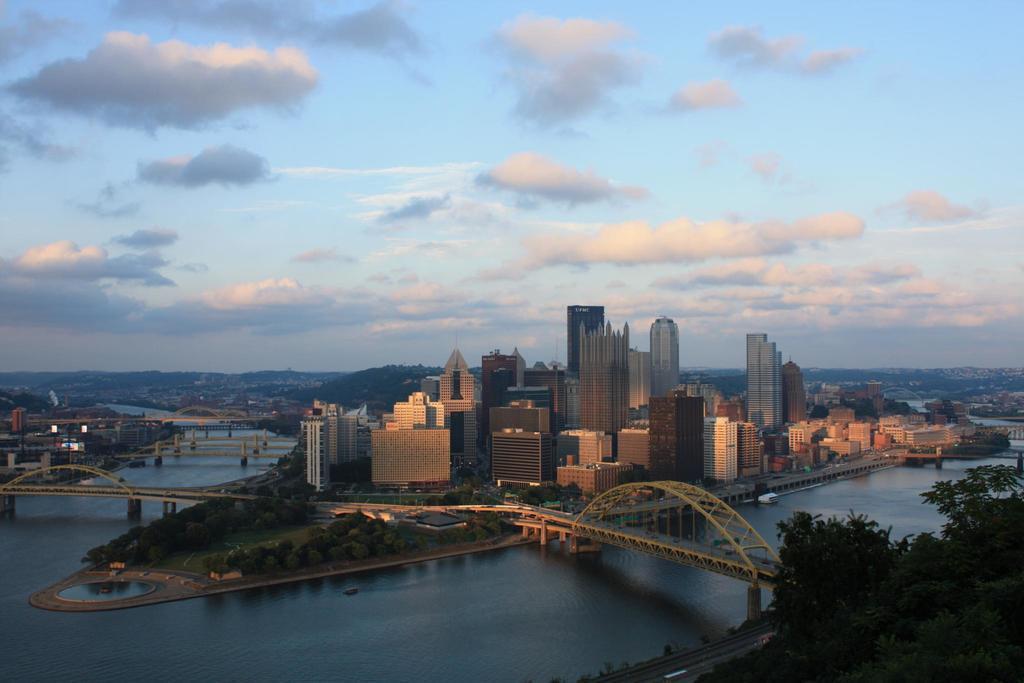Could you give a brief overview of what you see in this image? In this image there are bridges on the water. There are few trees and buildings are on the land. There are hills. Top of image there is sky with some clouds. Right bottom there are trees. Beside there are few vehicles on the road. 